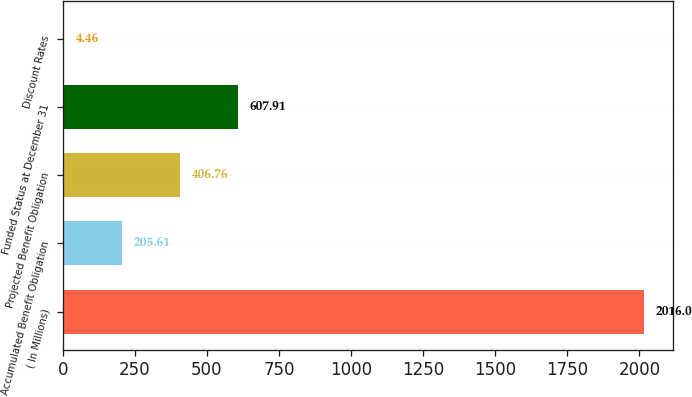Convert chart. <chart><loc_0><loc_0><loc_500><loc_500><bar_chart><fcel>( In Millions)<fcel>Accumulated Benefit Obligation<fcel>Projected Benefit Obligation<fcel>Funded Status at December 31<fcel>Discount Rates<nl><fcel>2016<fcel>205.61<fcel>406.76<fcel>607.91<fcel>4.46<nl></chart> 